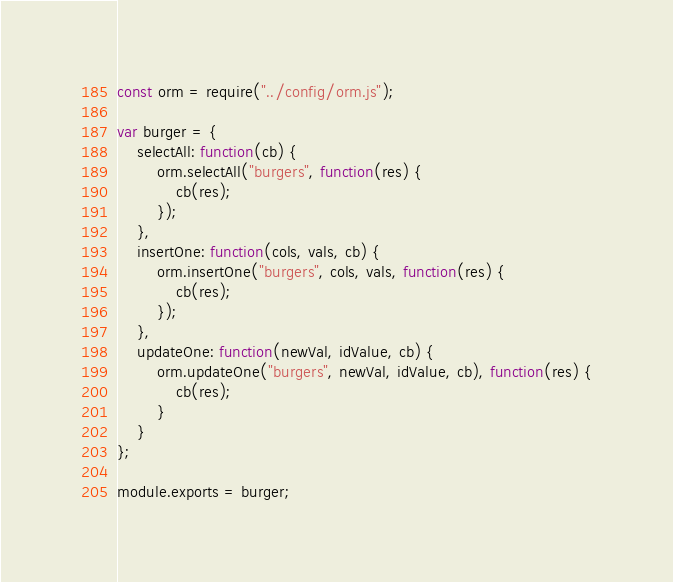Convert code to text. <code><loc_0><loc_0><loc_500><loc_500><_JavaScript_>const orm = require("../config/orm.js");

var burger = {
    selectAll: function(cb) {
        orm.selectAll("burgers", function(res) {
            cb(res);
        });
    },
    insertOne: function(cols, vals, cb) {
        orm.insertOne("burgers", cols, vals, function(res) {
            cb(res);
        });
    },
    updateOne: function(newVal, idValue, cb) {
        orm.updateOne("burgers", newVal, idValue, cb), function(res) {
            cb(res);
        }
    }
};

module.exports = burger;</code> 